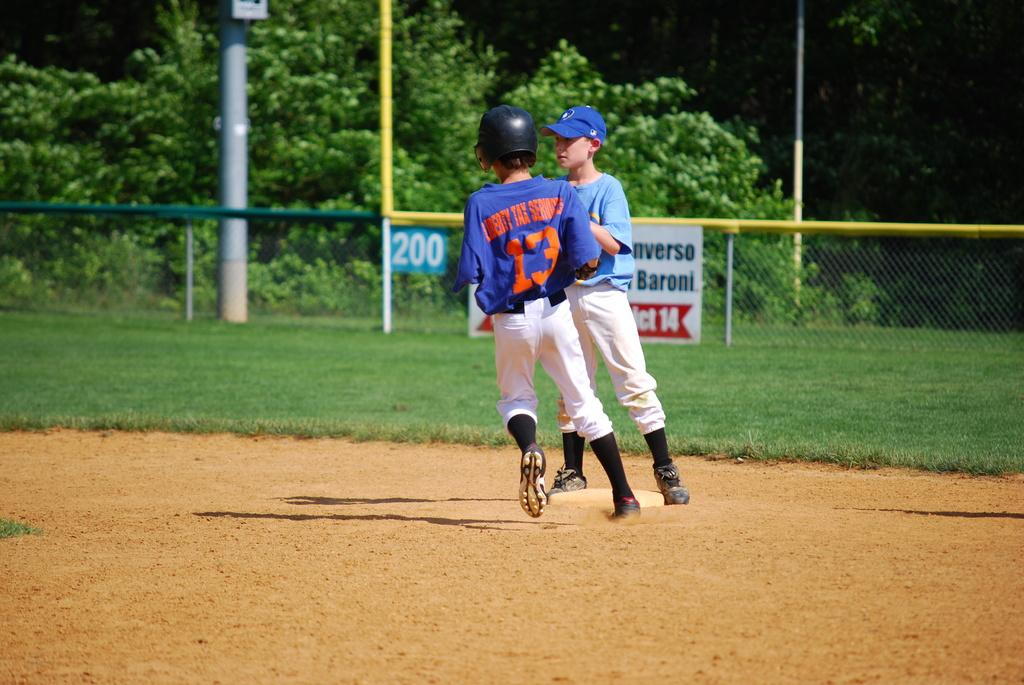<image>
Share a concise interpretation of the image provided. A Little League player in a Liberty Tax Services uniform rounds the bases. 